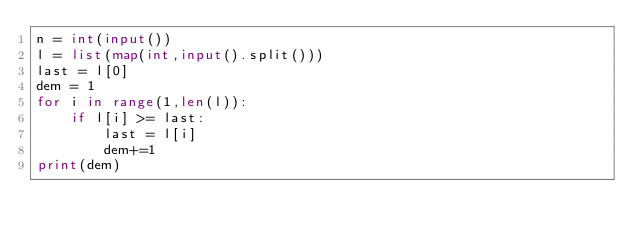<code> <loc_0><loc_0><loc_500><loc_500><_Python_>n = int(input())
l = list(map(int,input().split()))
last = l[0]
dem = 1
for i in range(1,len(l)):
    if l[i] >= last:
        last = l[i]
        dem+=1
print(dem)</code> 